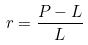<formula> <loc_0><loc_0><loc_500><loc_500>r = \frac { P - L } { L }</formula> 